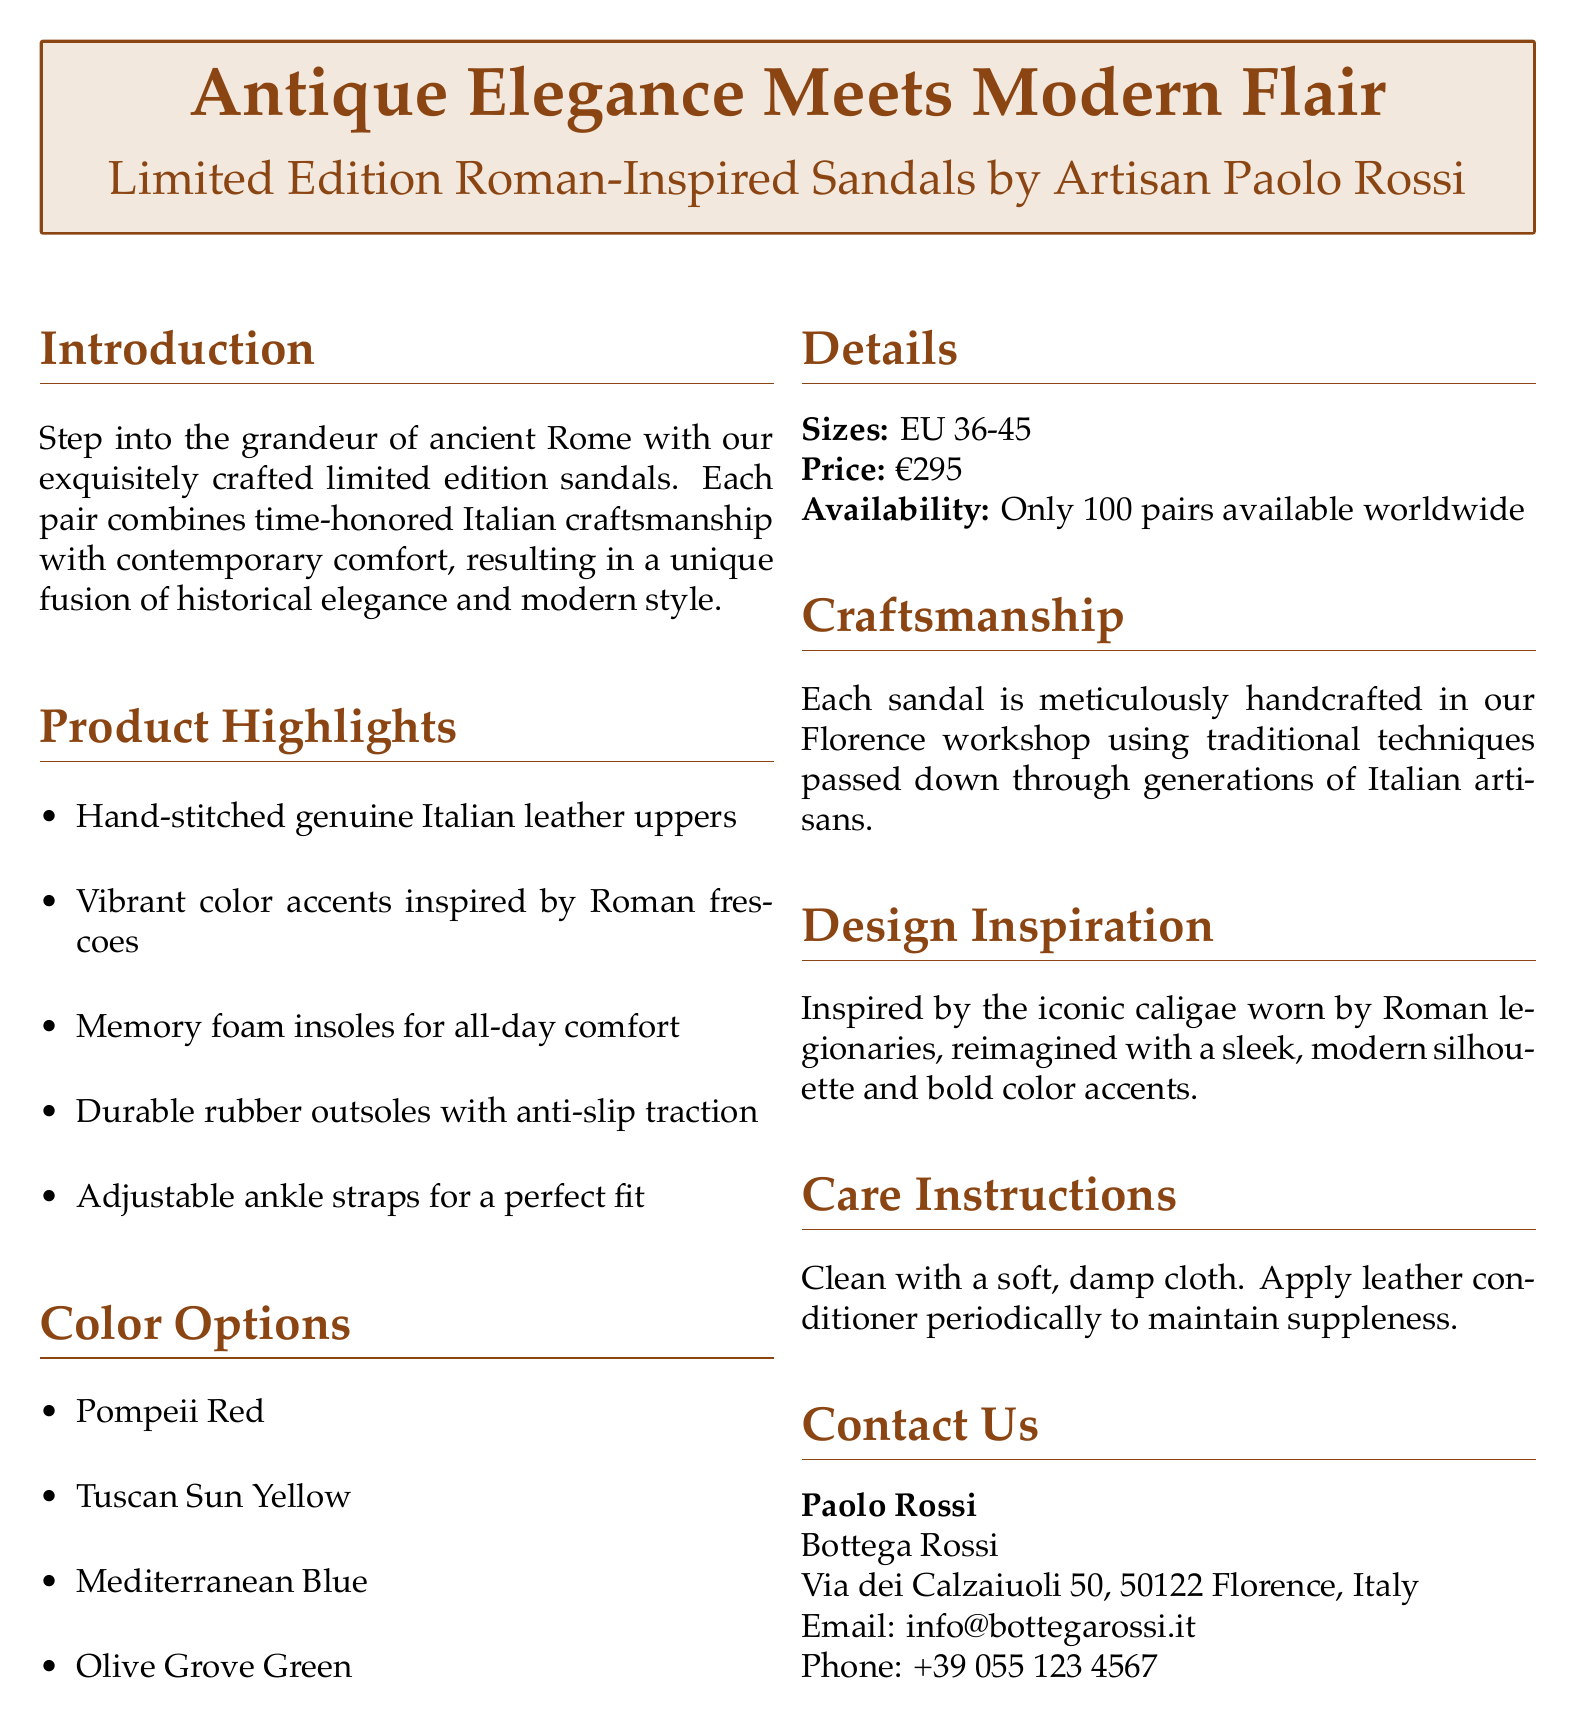What is the product name? The product name is mentioned in the title - "Limited Edition Roman-Inspired Sandals."
Answer: Limited Edition Roman-Inspired Sandals What colors are available? The document lists the color options available for the sandals, which include four specific colors.
Answer: Pompeii Red, Tuscan Sun Yellow, Mediterranean Blue, Olive Grove Green What is the price of the sandals? The price is clearly stated in the details section of the document.
Answer: €295 How many pairs are available worldwide? The document specifies the availability of the sandals in terms of quantity.
Answer: 100 pairs What type of leather is used for the uppers? The product highlights mention the material used for the uppers of the sandals.
Answer: Genuine Italian leather Who is the artisan behind the sandals? The artisan's name is provided in the introduction section of the document.
Answer: Paolo Rossi What is the size range for the sandals? The sizes of the sandals are specified in the details section of the document.
Answer: EU 36-45 What feature provides comfort for all-day wear? The product highlights mention a specific feature that enhances comfort.
Answer: Memory foam insoles What city is the workshop located in? The contact information provides the location of the artisan's workshop.
Answer: Florence 